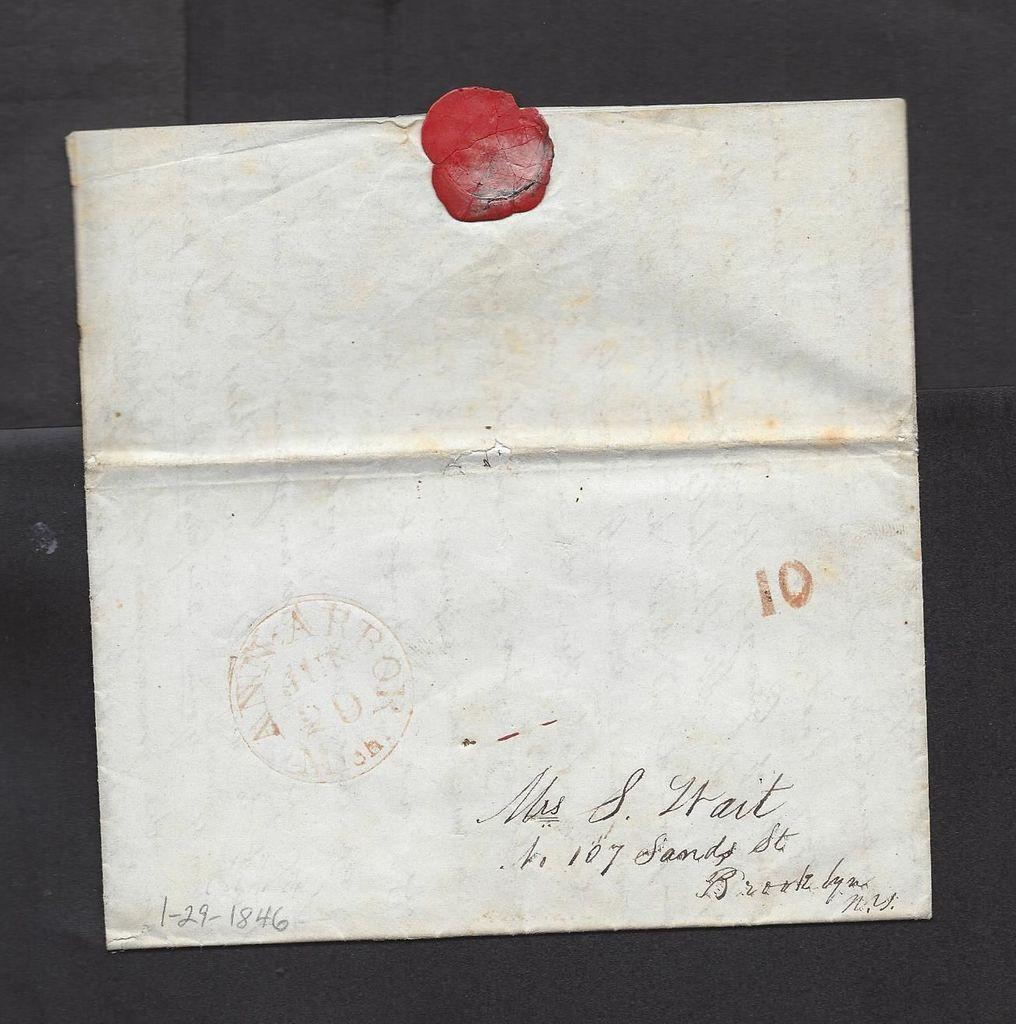<image>
Summarize the visual content of the image. An aged white letter sealed with red wax addressed to Mrs. S Lrait. 